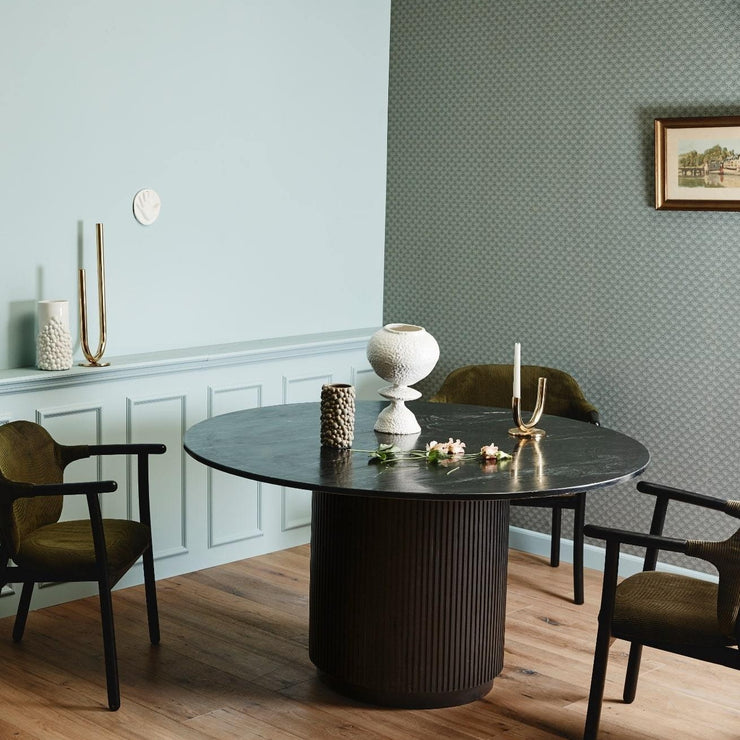What might be the function of this room based on the furniture and layout? Based on the furnishings and layout, this room appears to function as a dining area. The presence of a large table as a central piece, accompanied by chairs, suggests a space designed for meal consumption and social gatherings. 